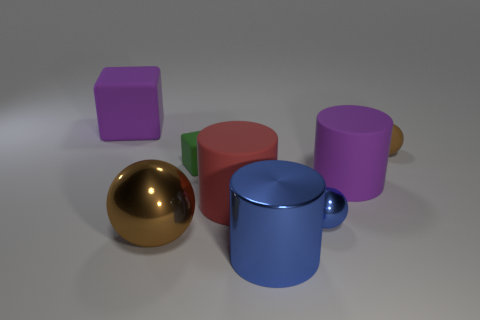Subtract all brown cubes. How many brown balls are left? 2 Subtract all brown spheres. How many spheres are left? 1 Subtract 1 cylinders. How many cylinders are left? 2 Add 1 large purple matte cylinders. How many objects exist? 9 Subtract all blocks. How many objects are left? 6 Subtract 0 gray spheres. How many objects are left? 8 Subtract all blue cylinders. Subtract all tiny green objects. How many objects are left? 6 Add 4 large purple matte cylinders. How many large purple matte cylinders are left? 5 Add 6 large gray matte blocks. How many large gray matte blocks exist? 6 